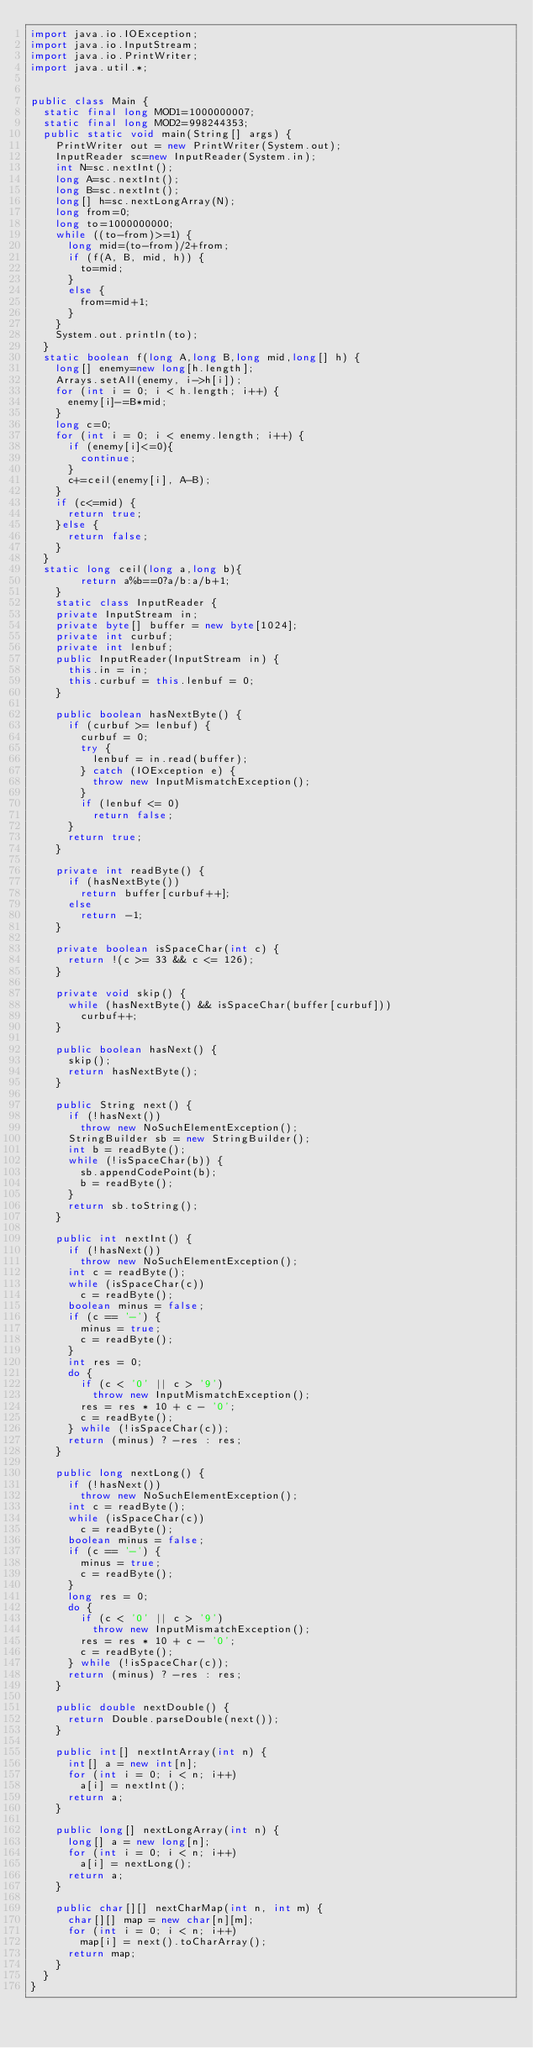<code> <loc_0><loc_0><loc_500><loc_500><_Java_>import java.io.IOException;
import java.io.InputStream;
import java.io.PrintWriter;
import java.util.*;

 
public class Main {
	static final long MOD1=1000000007;
	static final long MOD2=998244353;
	public static void main(String[] args) {
		PrintWriter out = new PrintWriter(System.out);
		InputReader sc=new InputReader(System.in);
		int N=sc.nextInt();
		long A=sc.nextInt();
		long B=sc.nextInt();
		long[] h=sc.nextLongArray(N);
		long from=0;
		long to=1000000000;
		while ((to-from)>=1) {
			long mid=(to-from)/2+from;
			if (f(A, B, mid, h)) {
				to=mid;
			}
			else {
				from=mid+1;
			}
		}
		System.out.println(to);
	}
	static boolean f(long A,long B,long mid,long[] h) {
		long[] enemy=new long[h.length];
		Arrays.setAll(enemy, i->h[i]);
		for (int i = 0; i < h.length; i++) {
			enemy[i]-=B*mid;
		}
		long c=0;
		for (int i = 0; i < enemy.length; i++) {
			if (enemy[i]<=0){
				continue;
			}
			c+=ceil(enemy[i], A-B);
		}
		if (c<=mid) {
			return true;
		}else {
			return false;
		}
	}
	static long ceil(long a,long b){
        return a%b==0?a/b:a/b+1;
    }
		static class InputReader { 
		private InputStream in;
		private byte[] buffer = new byte[1024];
		private int curbuf;
		private int lenbuf;
		public InputReader(InputStream in) {
			this.in = in;
			this.curbuf = this.lenbuf = 0;
		}
 
		public boolean hasNextByte() {
			if (curbuf >= lenbuf) {
				curbuf = 0;
				try {
					lenbuf = in.read(buffer);
				} catch (IOException e) {
					throw new InputMismatchException();
				}
				if (lenbuf <= 0)
					return false;
			}
			return true;
		}
 
		private int readByte() {
			if (hasNextByte())
				return buffer[curbuf++];
			else
				return -1;
		}
 
		private boolean isSpaceChar(int c) {
			return !(c >= 33 && c <= 126);
		}
 
		private void skip() {
			while (hasNextByte() && isSpaceChar(buffer[curbuf]))
				curbuf++;
		}
 
		public boolean hasNext() {
			skip();
			return hasNextByte();
		}
 
		public String next() {
			if (!hasNext())
				throw new NoSuchElementException();
			StringBuilder sb = new StringBuilder();
			int b = readByte();
			while (!isSpaceChar(b)) {
				sb.appendCodePoint(b);
				b = readByte();
			}
			return sb.toString();
		}
 
		public int nextInt() {
			if (!hasNext())
				throw new NoSuchElementException();
			int c = readByte();
			while (isSpaceChar(c))
				c = readByte();
			boolean minus = false;
			if (c == '-') {
				minus = true;
				c = readByte();
			}
			int res = 0;
			do {
				if (c < '0' || c > '9')
					throw new InputMismatchException();
				res = res * 10 + c - '0';
				c = readByte();
			} while (!isSpaceChar(c));
			return (minus) ? -res : res;
		}
 
		public long nextLong() {
			if (!hasNext())
				throw new NoSuchElementException();
			int c = readByte();
			while (isSpaceChar(c))
				c = readByte();
			boolean minus = false;
			if (c == '-') {
				minus = true;
				c = readByte();
			}
			long res = 0;
			do {
				if (c < '0' || c > '9')
					throw new InputMismatchException();
				res = res * 10 + c - '0';
				c = readByte();
			} while (!isSpaceChar(c));
			return (minus) ? -res : res;
		}
 
		public double nextDouble() {
			return Double.parseDouble(next());
		}
 
		public int[] nextIntArray(int n) {
			int[] a = new int[n];
			for (int i = 0; i < n; i++)
				a[i] = nextInt();
			return a;
		}
 
		public long[] nextLongArray(int n) {
			long[] a = new long[n];
			for (int i = 0; i < n; i++)
				a[i] = nextLong();
			return a;
		}
 
		public char[][] nextCharMap(int n, int m) {
			char[][] map = new char[n][m];
			for (int i = 0; i < n; i++)
				map[i] = next().toCharArray();
			return map;
		}
	}
}
</code> 